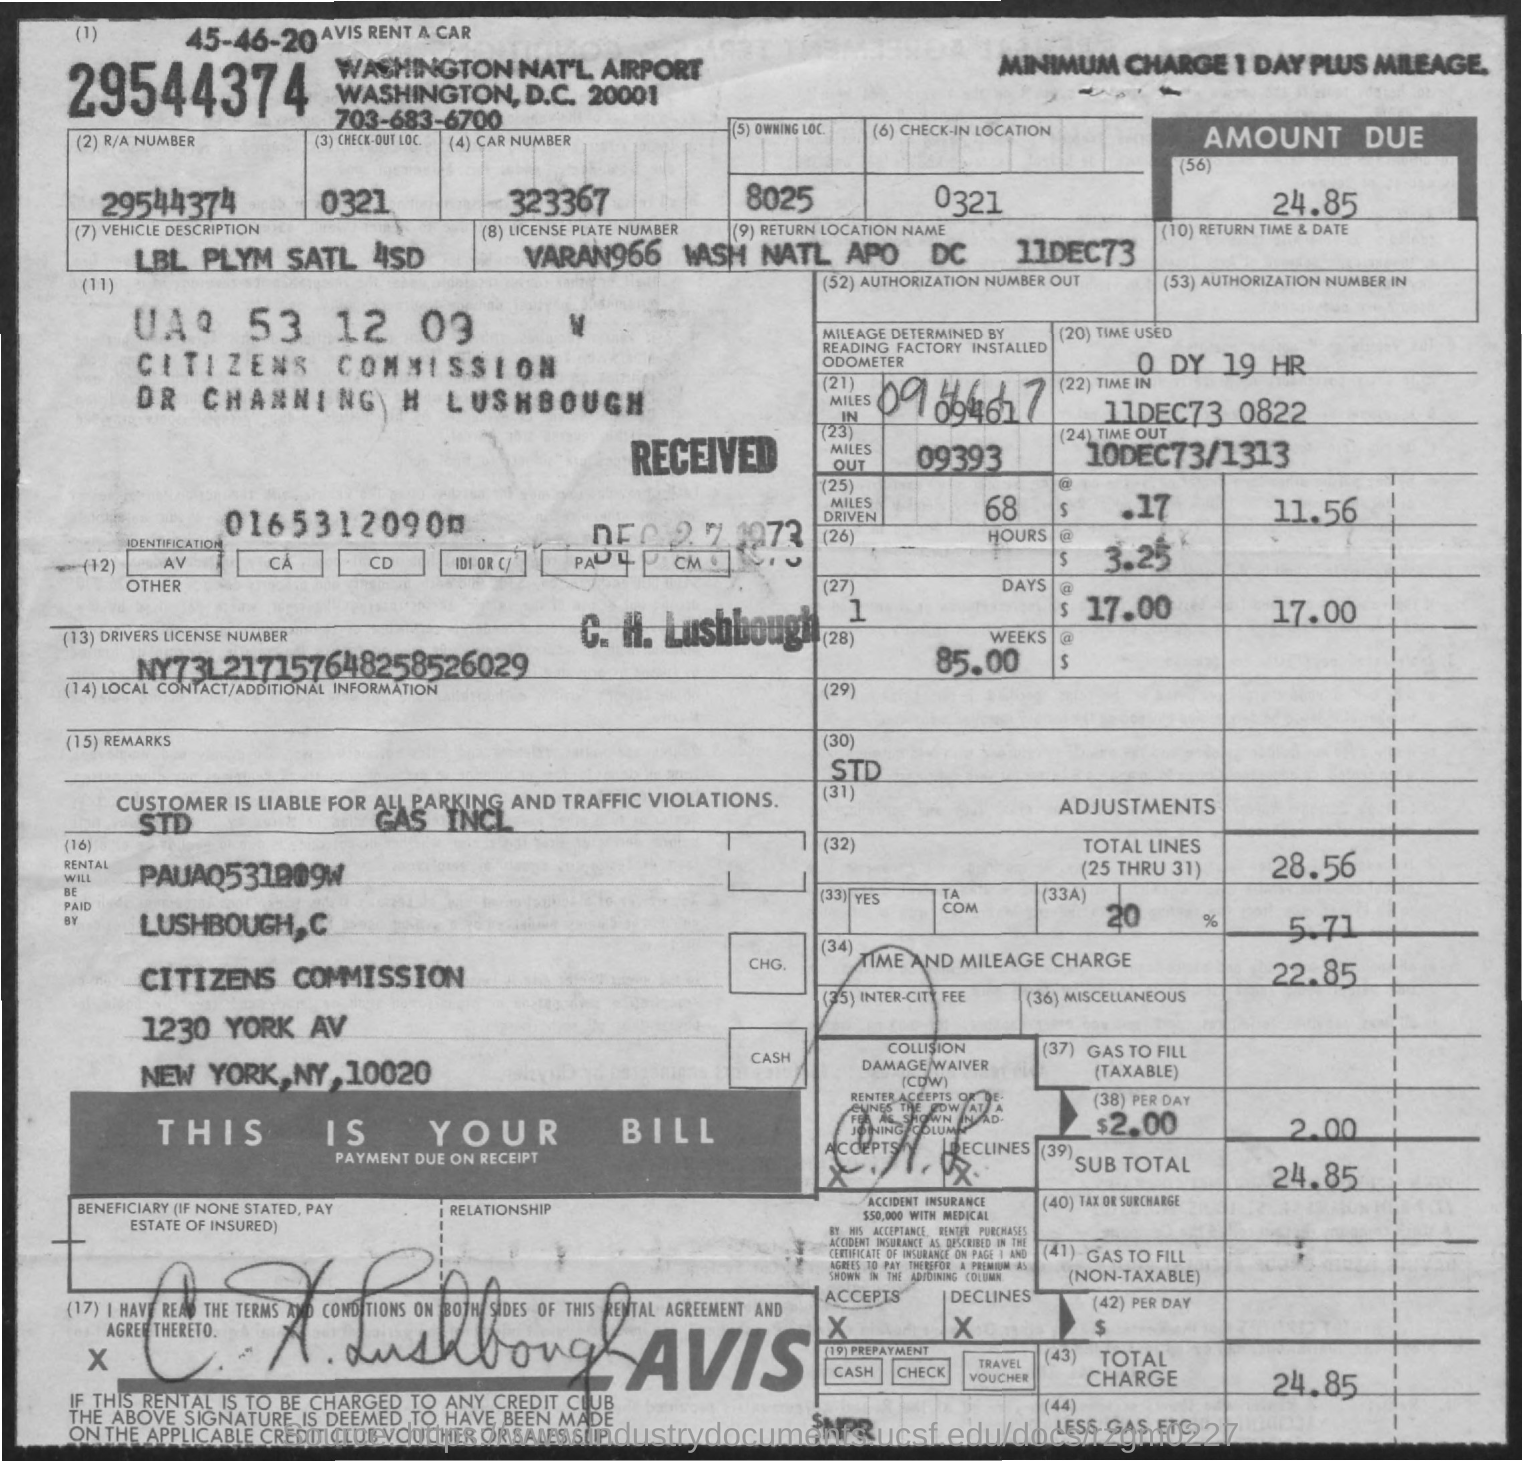Give some essential details in this illustration. The time and mileage charge is 22.85. The document provides a description of a vehicle, which is listed as LBL PLYM SATL 4SD. The amount due, as per the document, is 24.85. The driver's license number mentioned in the document is NY73L217157648258526029. The time mentioned in the document is 0 days and 19 hours. 